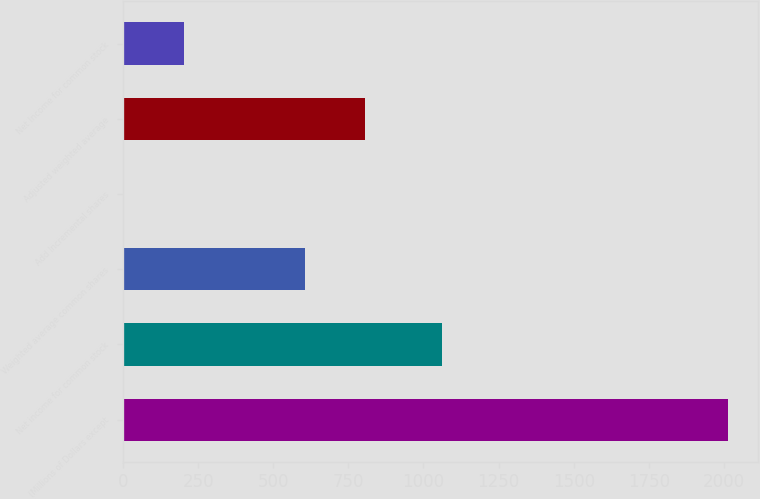Convert chart to OTSL. <chart><loc_0><loc_0><loc_500><loc_500><bar_chart><fcel>(Millions of Dollars except<fcel>Net income for common stock<fcel>Weighted average common shares<fcel>Add Incremental shares<fcel>Adjusted weighted average<fcel>Net Income for common stock<nl><fcel>2013<fcel>1062<fcel>604.95<fcel>1.5<fcel>806.1<fcel>202.65<nl></chart> 